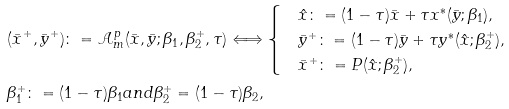<formula> <loc_0><loc_0><loc_500><loc_500>& ( \bar { x } ^ { + } , \bar { y } ^ { + } ) \colon = \mathcal { A } ^ { p } _ { m } ( \bar { x } , \bar { y } ; \beta _ { 1 } , \beta _ { 2 } ^ { + } , \tau ) \Longleftrightarrow \begin{cases} & \hat { x } \colon = ( 1 - \tau ) \bar { x } + \tau x ^ { * } ( \bar { y } ; \beta _ { 1 } ) , \\ & \bar { y } ^ { + } \colon = ( 1 - \tau ) \bar { y } + \tau y ^ { * } ( \hat { x } ; \beta _ { 2 } ^ { + } ) , \\ & \bar { x } ^ { + } \colon = P ( \hat { x } ; \beta _ { 2 } ^ { + } ) , \end{cases} \\ & \beta _ { 1 } ^ { + } \colon = ( 1 - \tau ) \beta _ { 1 } a n d \beta _ { 2 } ^ { + } = ( 1 - \tau ) \beta _ { 2 } ,</formula> 